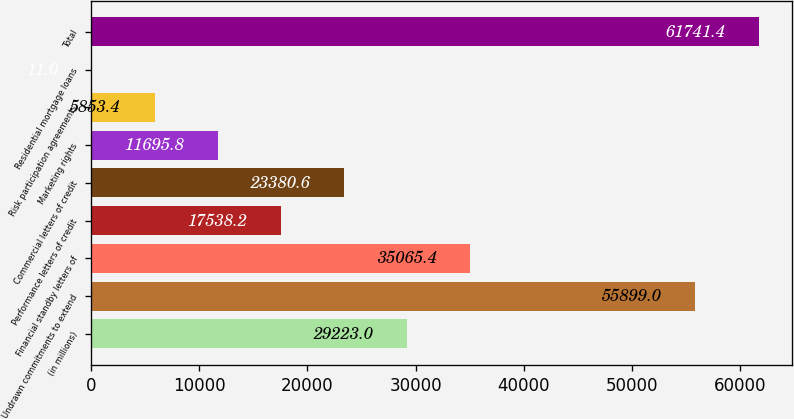Convert chart to OTSL. <chart><loc_0><loc_0><loc_500><loc_500><bar_chart><fcel>(in millions)<fcel>Undrawn commitments to extend<fcel>Financial standby letters of<fcel>Performance letters of credit<fcel>Commercial letters of credit<fcel>Marketing rights<fcel>Risk participation agreements<fcel>Residential mortgage loans<fcel>Total<nl><fcel>29223<fcel>55899<fcel>35065.4<fcel>17538.2<fcel>23380.6<fcel>11695.8<fcel>5853.4<fcel>11<fcel>61741.4<nl></chart> 